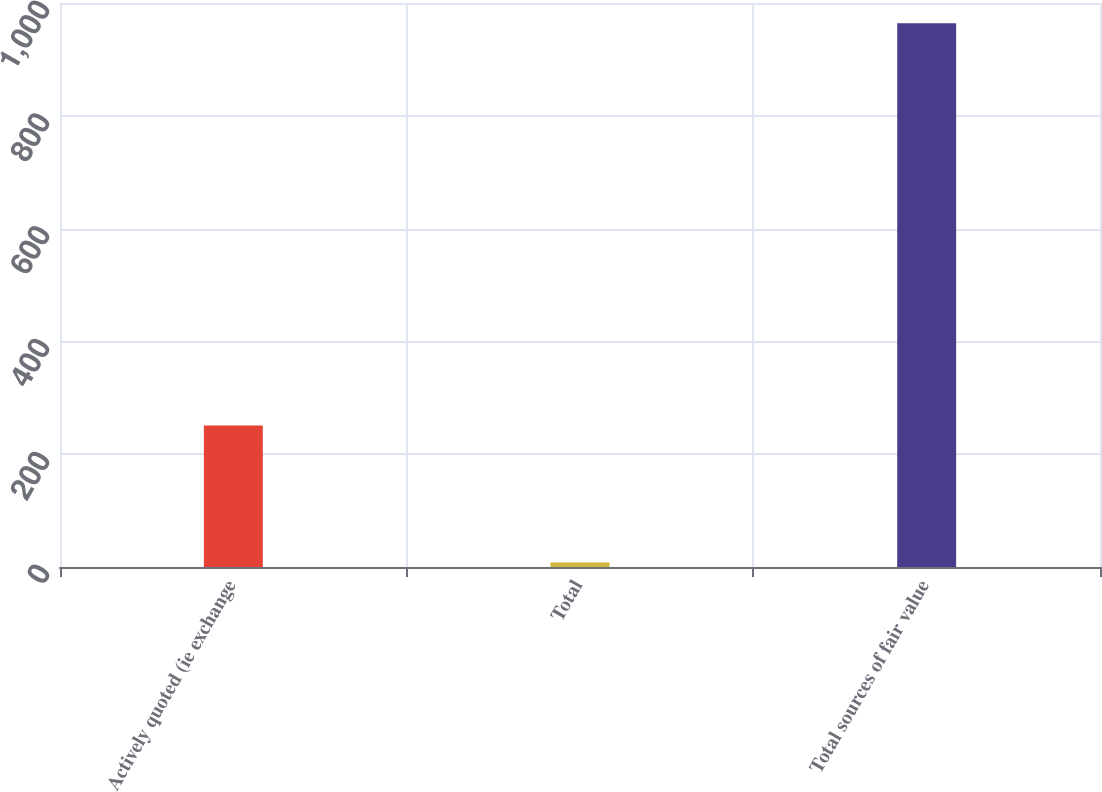<chart> <loc_0><loc_0><loc_500><loc_500><bar_chart><fcel>Actively quoted (ie exchange<fcel>Total<fcel>Total sources of fair value<nl><fcel>251<fcel>8<fcel>964<nl></chart> 